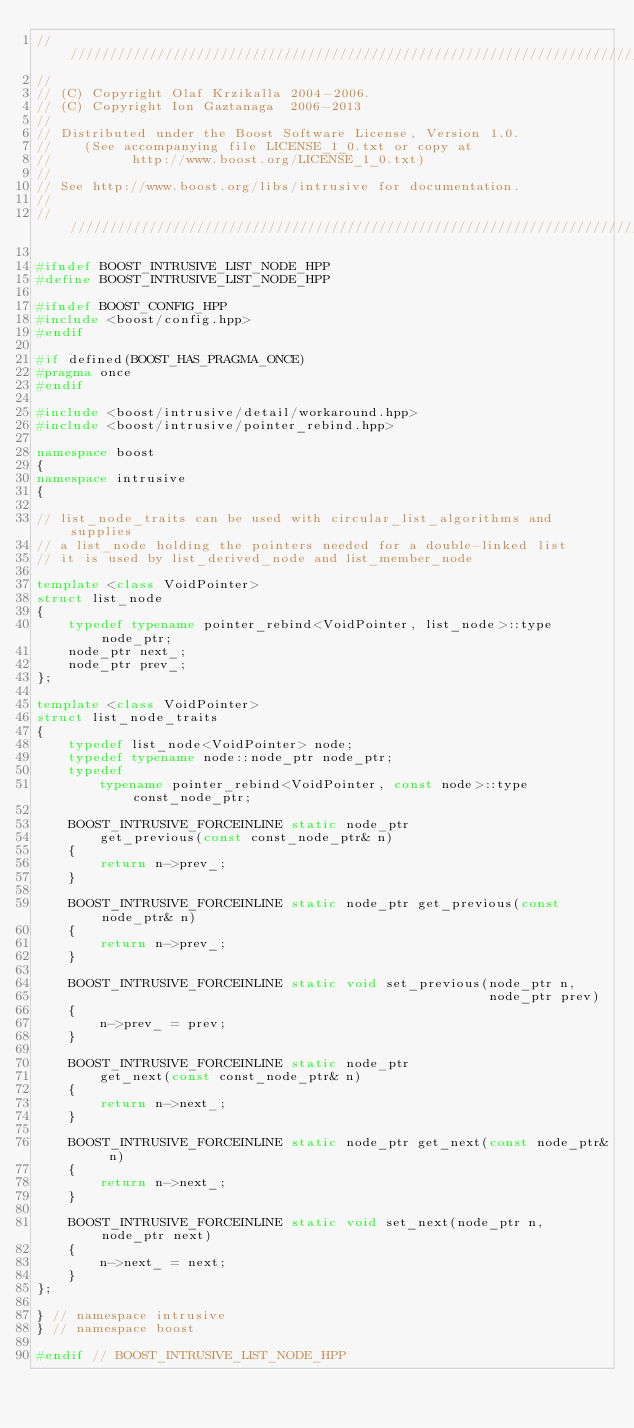<code> <loc_0><loc_0><loc_500><loc_500><_C++_>/////////////////////////////////////////////////////////////////////////////
//
// (C) Copyright Olaf Krzikalla 2004-2006.
// (C) Copyright Ion Gaztanaga  2006-2013
//
// Distributed under the Boost Software License, Version 1.0.
//    (See accompanying file LICENSE_1_0.txt or copy at
//          http://www.boost.org/LICENSE_1_0.txt)
//
// See http://www.boost.org/libs/intrusive for documentation.
//
/////////////////////////////////////////////////////////////////////////////

#ifndef BOOST_INTRUSIVE_LIST_NODE_HPP
#define BOOST_INTRUSIVE_LIST_NODE_HPP

#ifndef BOOST_CONFIG_HPP
#include <boost/config.hpp>
#endif

#if defined(BOOST_HAS_PRAGMA_ONCE)
#pragma once
#endif

#include <boost/intrusive/detail/workaround.hpp>
#include <boost/intrusive/pointer_rebind.hpp>

namespace boost
{
namespace intrusive
{

// list_node_traits can be used with circular_list_algorithms and supplies
// a list_node holding the pointers needed for a double-linked list
// it is used by list_derived_node and list_member_node

template <class VoidPointer>
struct list_node
{
    typedef typename pointer_rebind<VoidPointer, list_node>::type node_ptr;
    node_ptr next_;
    node_ptr prev_;
};

template <class VoidPointer>
struct list_node_traits
{
    typedef list_node<VoidPointer> node;
    typedef typename node::node_ptr node_ptr;
    typedef
        typename pointer_rebind<VoidPointer, const node>::type const_node_ptr;

    BOOST_INTRUSIVE_FORCEINLINE static node_ptr
        get_previous(const const_node_ptr& n)
    {
        return n->prev_;
    }

    BOOST_INTRUSIVE_FORCEINLINE static node_ptr get_previous(const node_ptr& n)
    {
        return n->prev_;
    }

    BOOST_INTRUSIVE_FORCEINLINE static void set_previous(node_ptr n,
                                                         node_ptr prev)
    {
        n->prev_ = prev;
    }

    BOOST_INTRUSIVE_FORCEINLINE static node_ptr
        get_next(const const_node_ptr& n)
    {
        return n->next_;
    }

    BOOST_INTRUSIVE_FORCEINLINE static node_ptr get_next(const node_ptr& n)
    {
        return n->next_;
    }

    BOOST_INTRUSIVE_FORCEINLINE static void set_next(node_ptr n, node_ptr next)
    {
        n->next_ = next;
    }
};

} // namespace intrusive
} // namespace boost

#endif // BOOST_INTRUSIVE_LIST_NODE_HPP
</code> 